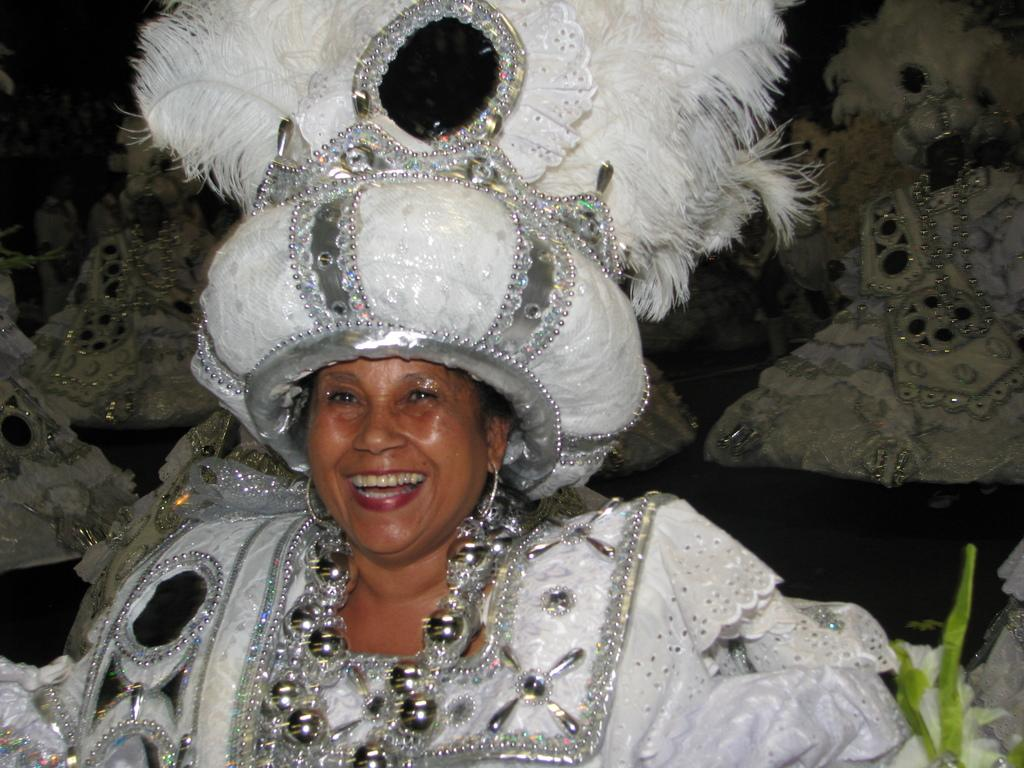Who is the main subject in the image? There is a woman in the image. What is the woman wearing? The woman is wearing a white dress. What can be seen on the right side of the image? There is a small plant on the right side of the image. What is visible in the background of the image? There are many people in the background of the image. What type of wren can be seen singing in the image? There is no wren present in the image; it features a woman wearing a white dress and a small plant on the right side. How long has the woman been quiet in the image? The provided facts do not mention any information about the woman's silence or lack thereof, so it cannot be determined from the image. 